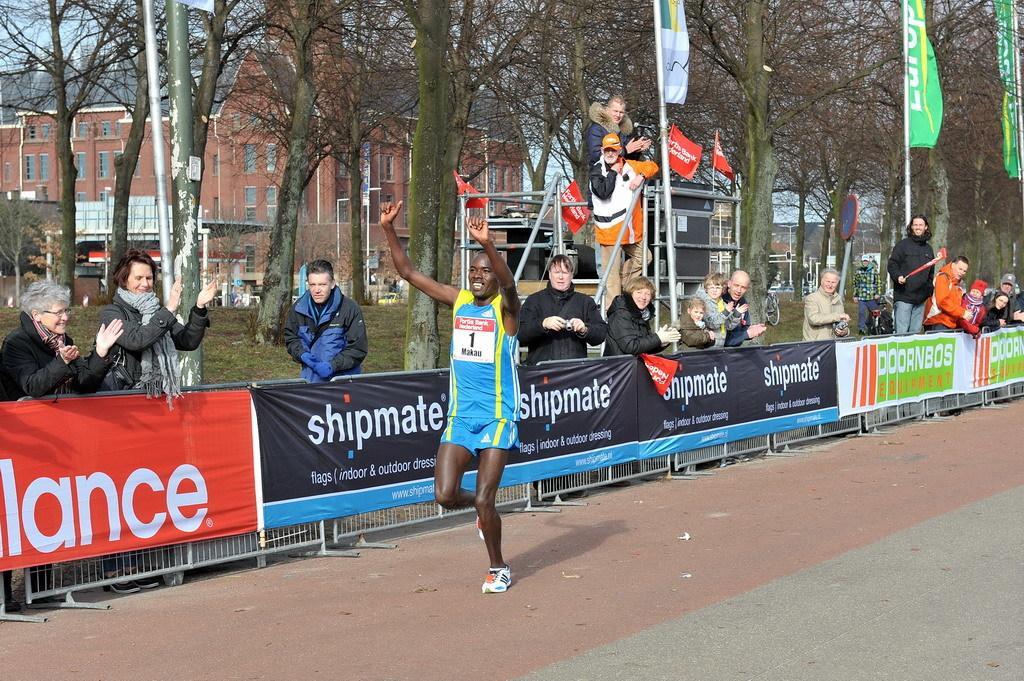How would you summarize this image in a sentence or two? In this picture I can see there is a person running and there are few people cheering up and in the backdrop there are trees and buildings. 